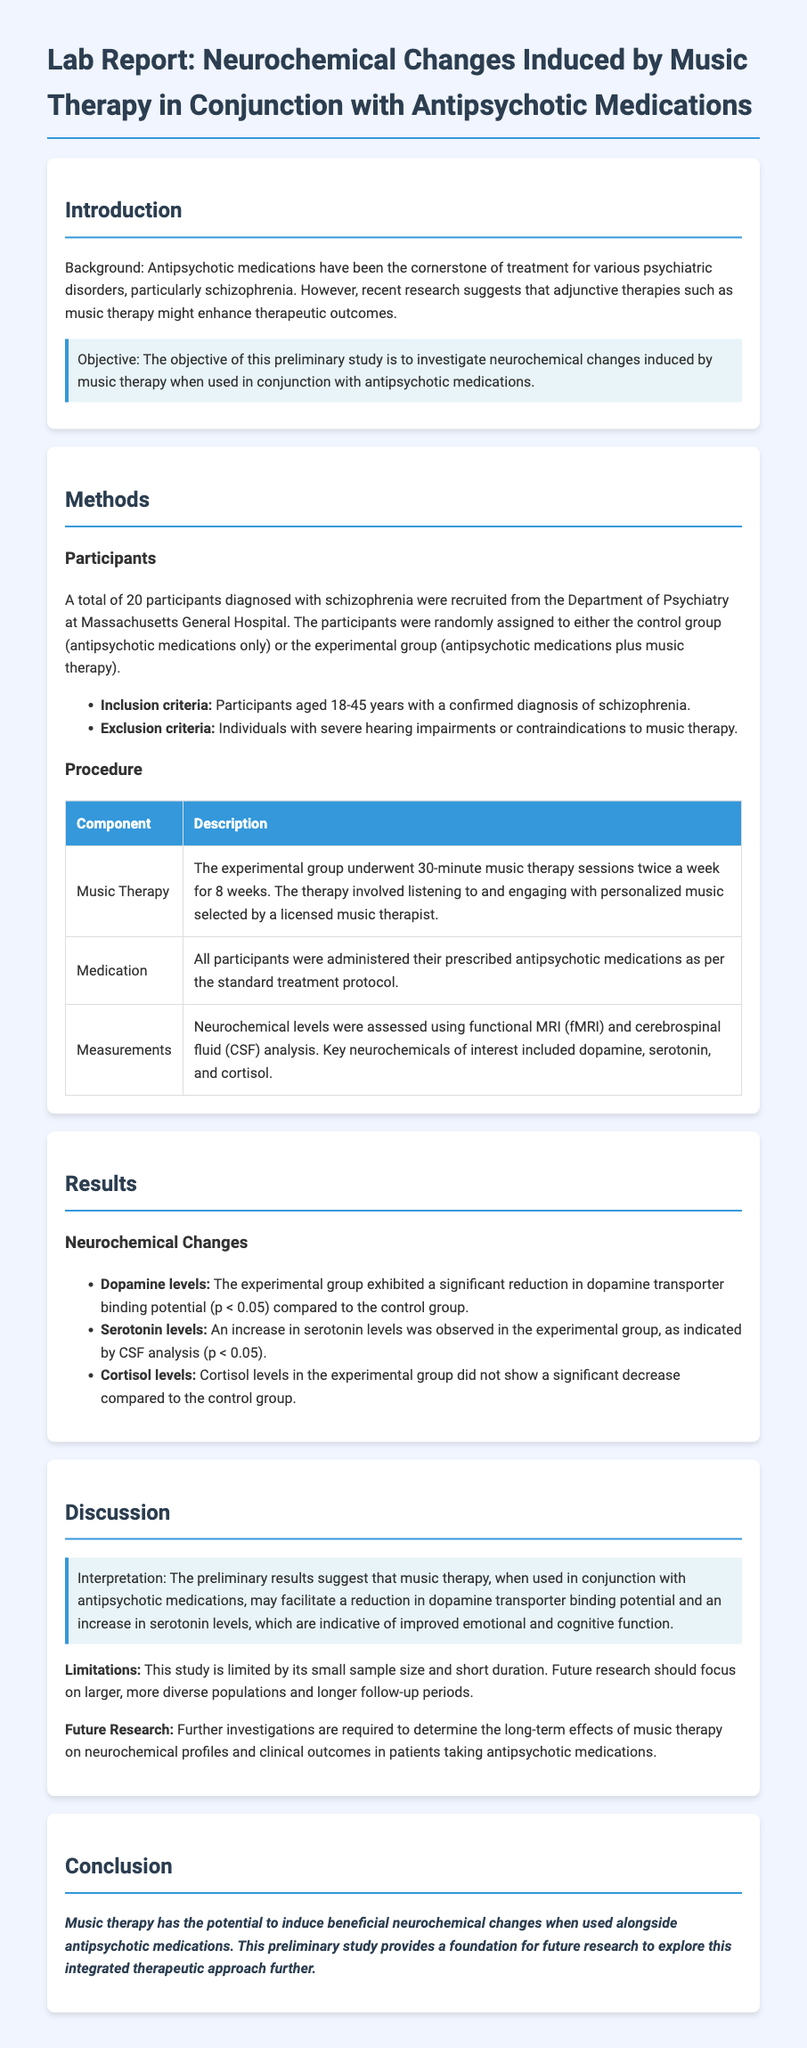What is the main objective of the study? The objective of this preliminary study is stated in the introduction as investigating neurochemical changes induced by music therapy when used in conjunction with antipsychotic medications.
Answer: Investigate neurochemical changes How many participants were in the study? The report states that a total of 20 participants were recruited for the study.
Answer: 20 participants What were the inclusion criteria for participants? The report mentions that participants needed to be aged 18-45 years with a confirmed diagnosis of schizophrenia as the inclusion criteria.
Answer: Aged 18-45 years with schizophrenia Which neurochemical levels increased in the experimental group? The results indicate that an increase in serotonin levels was observed in the experimental group.
Answer: Serotonin levels What tool was used to assess neurochemical levels? The methods section specifies that neurochemical levels were assessed using functional MRI and cerebrospinal fluid analysis.
Answer: Functional MRI and CSF analysis What is a limitation of the study mentioned in the discussion? The discussion highlights that the study is limited by its small sample size and short duration.
Answer: Small sample size and short duration What neurochemical showed no significant decrease in the experimental group? According to the results, cortisol levels in the experimental group did not show a significant decrease compared to the control group.
Answer: Cortisol levels What is suggested for future research? The discussion states that further investigations are required to determine the long-term effects of music therapy on neurochemical profiles and clinical outcomes.
Answer: Long-term effects of music therapy What type of therapy was administered twice a week? The methods section describes music therapy as the type of therapy given to the experimental group twice a week for 8 weeks.
Answer: Music therapy 